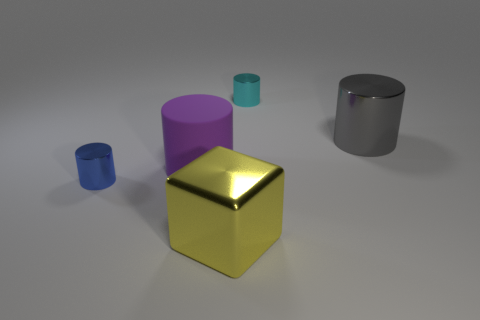What number of big things are purple cylinders or brown metallic things?
Make the answer very short. 1. The large cylinder that is the same material as the yellow thing is what color?
Offer a very short reply. Gray. There is a tiny thing that is left of the cyan cylinder; is its shape the same as the large metal thing in front of the large purple matte cylinder?
Give a very brief answer. No. What number of metal things are cyan cylinders or big cylinders?
Your response must be concise. 2. Are there any other things that have the same shape as the big purple object?
Offer a terse response. Yes. What is the material of the large cylinder that is in front of the gray metal object?
Offer a terse response. Rubber. Is the small cylinder that is behind the rubber cylinder made of the same material as the large cube?
Your answer should be very brief. Yes. What number of objects are either large yellow metallic blocks or tiny objects left of the large cube?
Make the answer very short. 2. What is the size of the purple rubber object that is the same shape as the small cyan metal thing?
Provide a succinct answer. Large. There is a large yellow shiny thing; are there any cyan metal objects to the left of it?
Make the answer very short. No. 